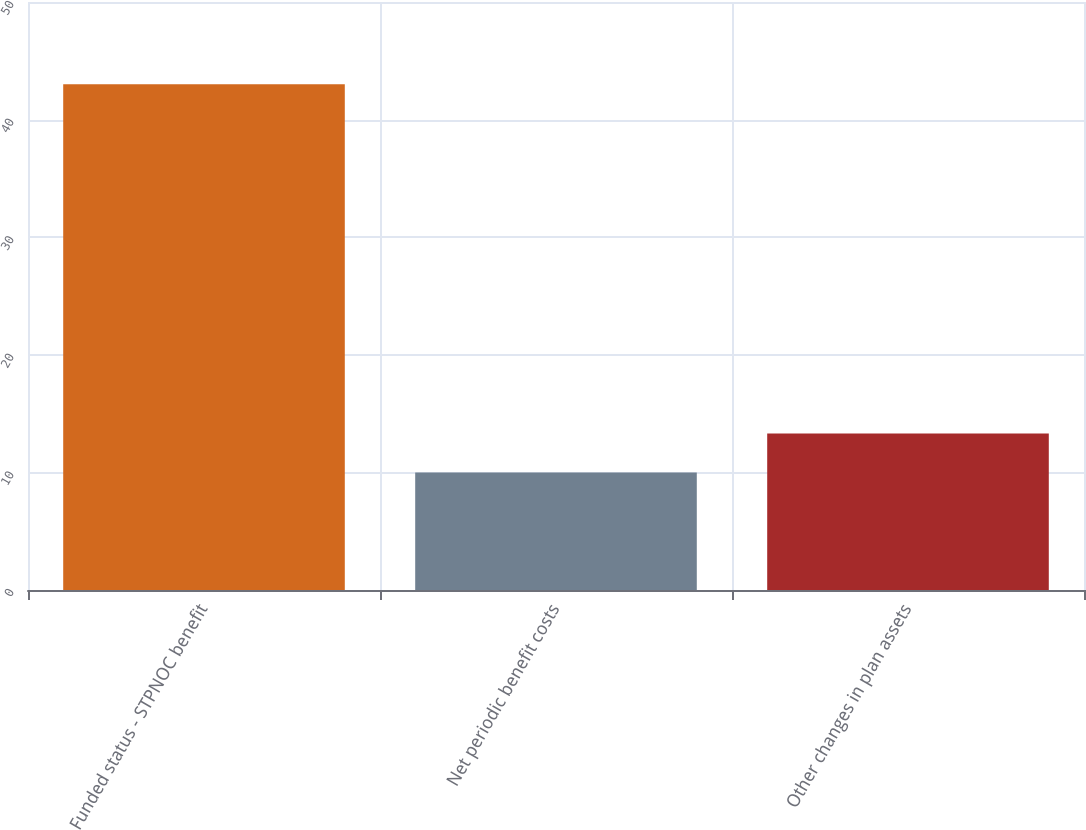Convert chart to OTSL. <chart><loc_0><loc_0><loc_500><loc_500><bar_chart><fcel>Funded status - STPNOC benefit<fcel>Net periodic benefit costs<fcel>Other changes in plan assets<nl><fcel>43<fcel>10<fcel>13.3<nl></chart> 